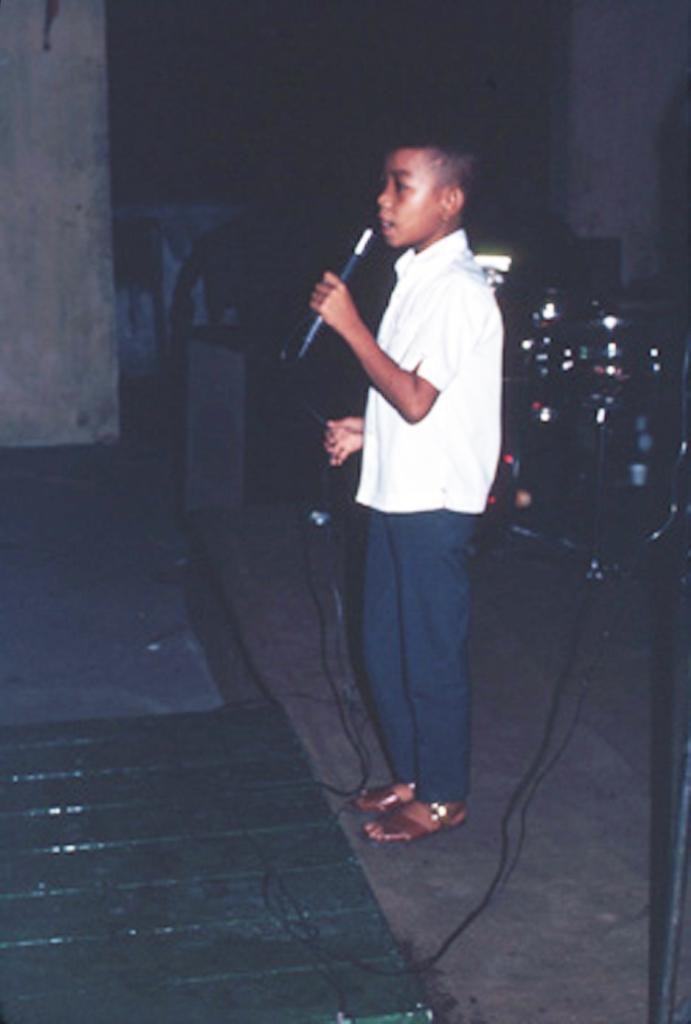What is the main subject of the image? The main subject of the image is a child. What is the child doing in the image? The child is standing on the floor and holding a mic with a wire. What else can be seen in the image besides the child? There are musical instruments visible in the image. What is visible in the background of the image? There is a wall in the background of the image. What type of flesh can be seen on the wall in the image? There is no flesh visible on the wall in the image; it is a solid structure. What is the weather like in the image? The provided facts do not mention any information about the weather, so it cannot be determined from the image. 